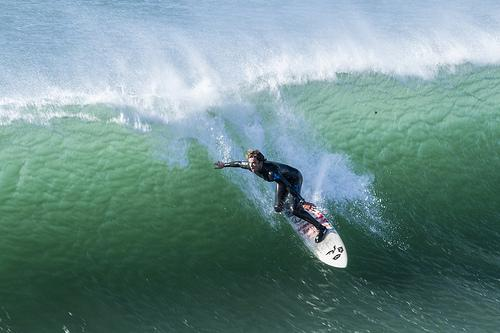Describe the scene from the perspective of a bystander observing the surfing event. From the shoreline, I could see a talented surfer with curly blond hair conquering a massive, green-colored wave on his striking white surfboard adorned with red stripes and black decals. Select three distinct visual elements from the image, and explain how they contribute to the overall atmosphere and action. The white spray and foam from the wave create a sense of movement and energy; the surfer's pose captures a moment of balance and skill; and the vibrant colors of the surfboard attract attention and contribute to a lively, adventurous atmosphere. Imagine you are describing the image to someone who can't see it. Offer a vivid and detailed description. In the image, a curly blond-haired surfer wearing a black wetsuit with a blue logo skillfully rides a large, cresting blue-green wave. He stands in balance atop a stunning white surfboard adorned with red stripes and black stickers, surrounded by white sea spray and ocean foam. The contrast between the calm waters in the background and the surging wave evokes a sense of excitement and danger. Mention the color and appearance of the wave and the ocean. The wave is a large, blue-green crest, while the ocean has a predominantly blue color with white spray and foam throughout. Describe the appearance and activities of the main individual in the photograph. The surfer has blond, curly hair and is wearing a black wetsuit with a blue logo while riding a wave on a white, red-striped surfboard. Provide a brief summary of the key components of the image. The image features a man in a wetsuit surfing on a large wave with a red and white surfboard, surrounded by ocean spray and foam. What is the rider wearing on his feet? The surfer is wearing black water shoes or surfing boots on his feet. If you were to create a painting based on this image, what elements would you emphasize? I would highlight the dynamic contrast between the calm waters behind the wave and the powerful, cresting wave itself, accentuating the surfer's impressive feat of riding the wave on his unique, white surfboard with red patterns. For a surfboard advertisement, highlight the surfboard's design and the surfer's skill level. Ride the waves with our custom-painted white surfboard featuring red stripes and black stickers – perfect for skilled surfers like the wetsuit-clad blond surfer showcased enjoying a thrilling ride on a large cresting wave. 